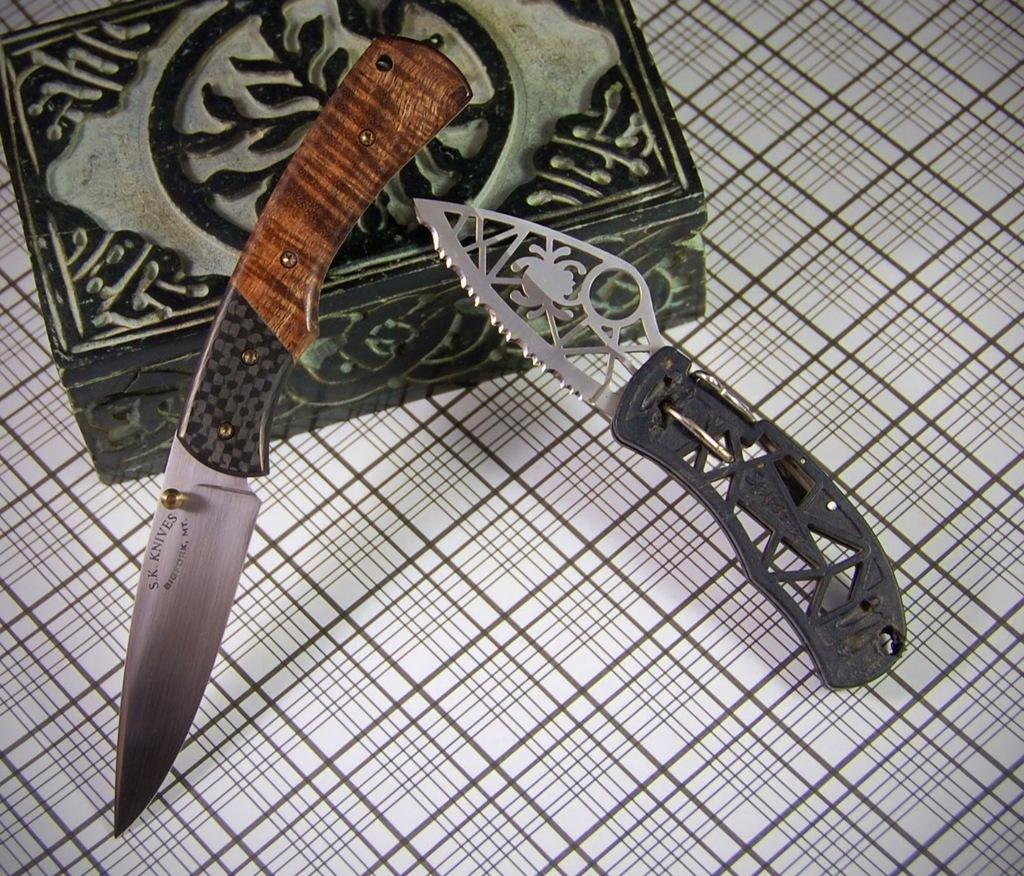What type of objects can be seen in the image? There are two hunting knives in the image. What else is present in the image besides the hunting knives? There is a box in the image. Where are the hunting knives and the box located? The hunting knives and the box are placed on a table. What type of reaction can be seen from the hunting knives during the rainstorm in the image? There is no rainstorm present in the image, and the hunting knives are inanimate objects, so they cannot have a reaction. 